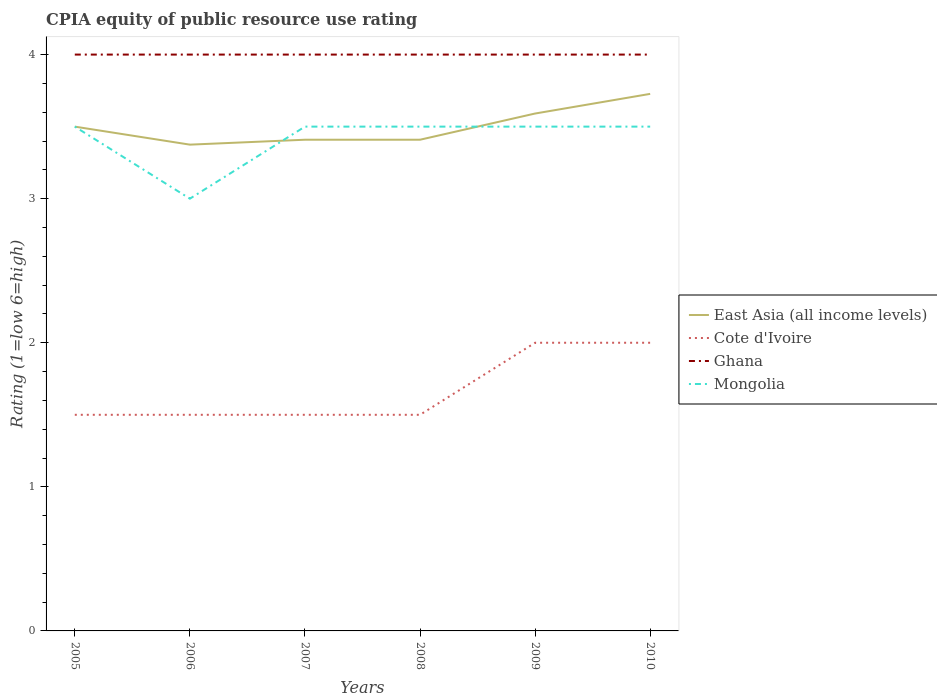How many different coloured lines are there?
Give a very brief answer. 4. Is the number of lines equal to the number of legend labels?
Ensure brevity in your answer.  Yes. Across all years, what is the maximum CPIA rating in East Asia (all income levels)?
Give a very brief answer. 3.38. What is the difference between the highest and the second highest CPIA rating in East Asia (all income levels)?
Give a very brief answer. 0.35. What is the difference between the highest and the lowest CPIA rating in Cote d'Ivoire?
Provide a succinct answer. 2. Does the graph contain grids?
Keep it short and to the point. No. Where does the legend appear in the graph?
Make the answer very short. Center right. How many legend labels are there?
Your answer should be very brief. 4. How are the legend labels stacked?
Provide a succinct answer. Vertical. What is the title of the graph?
Your response must be concise. CPIA equity of public resource use rating. What is the label or title of the X-axis?
Give a very brief answer. Years. What is the label or title of the Y-axis?
Ensure brevity in your answer.  Rating (1=low 6=high). What is the Rating (1=low 6=high) in East Asia (all income levels) in 2006?
Provide a succinct answer. 3.38. What is the Rating (1=low 6=high) of Cote d'Ivoire in 2006?
Your response must be concise. 1.5. What is the Rating (1=low 6=high) of Ghana in 2006?
Your response must be concise. 4. What is the Rating (1=low 6=high) in East Asia (all income levels) in 2007?
Give a very brief answer. 3.41. What is the Rating (1=low 6=high) of Cote d'Ivoire in 2007?
Your response must be concise. 1.5. What is the Rating (1=low 6=high) in Mongolia in 2007?
Offer a very short reply. 3.5. What is the Rating (1=low 6=high) of East Asia (all income levels) in 2008?
Your answer should be compact. 3.41. What is the Rating (1=low 6=high) in Cote d'Ivoire in 2008?
Make the answer very short. 1.5. What is the Rating (1=low 6=high) of Mongolia in 2008?
Your answer should be compact. 3.5. What is the Rating (1=low 6=high) of East Asia (all income levels) in 2009?
Offer a terse response. 3.59. What is the Rating (1=low 6=high) of Cote d'Ivoire in 2009?
Offer a very short reply. 2. What is the Rating (1=low 6=high) in Ghana in 2009?
Your answer should be very brief. 4. What is the Rating (1=low 6=high) of Mongolia in 2009?
Give a very brief answer. 3.5. What is the Rating (1=low 6=high) in East Asia (all income levels) in 2010?
Offer a terse response. 3.73. What is the Rating (1=low 6=high) in Mongolia in 2010?
Your answer should be compact. 3.5. Across all years, what is the maximum Rating (1=low 6=high) of East Asia (all income levels)?
Make the answer very short. 3.73. Across all years, what is the minimum Rating (1=low 6=high) in East Asia (all income levels)?
Provide a short and direct response. 3.38. What is the total Rating (1=low 6=high) in East Asia (all income levels) in the graph?
Offer a terse response. 21.01. What is the total Rating (1=low 6=high) of Cote d'Ivoire in the graph?
Offer a terse response. 10. What is the total Rating (1=low 6=high) in Ghana in the graph?
Provide a succinct answer. 24. What is the total Rating (1=low 6=high) of Mongolia in the graph?
Your response must be concise. 20.5. What is the difference between the Rating (1=low 6=high) in East Asia (all income levels) in 2005 and that in 2007?
Provide a succinct answer. 0.09. What is the difference between the Rating (1=low 6=high) in East Asia (all income levels) in 2005 and that in 2008?
Offer a terse response. 0.09. What is the difference between the Rating (1=low 6=high) in Cote d'Ivoire in 2005 and that in 2008?
Make the answer very short. 0. What is the difference between the Rating (1=low 6=high) of Ghana in 2005 and that in 2008?
Keep it short and to the point. 0. What is the difference between the Rating (1=low 6=high) of Mongolia in 2005 and that in 2008?
Ensure brevity in your answer.  0. What is the difference between the Rating (1=low 6=high) of East Asia (all income levels) in 2005 and that in 2009?
Your answer should be very brief. -0.09. What is the difference between the Rating (1=low 6=high) of East Asia (all income levels) in 2005 and that in 2010?
Your answer should be very brief. -0.23. What is the difference between the Rating (1=low 6=high) of Ghana in 2005 and that in 2010?
Offer a terse response. 0. What is the difference between the Rating (1=low 6=high) in East Asia (all income levels) in 2006 and that in 2007?
Your answer should be compact. -0.03. What is the difference between the Rating (1=low 6=high) of Ghana in 2006 and that in 2007?
Your answer should be compact. 0. What is the difference between the Rating (1=low 6=high) in Mongolia in 2006 and that in 2007?
Offer a very short reply. -0.5. What is the difference between the Rating (1=low 6=high) of East Asia (all income levels) in 2006 and that in 2008?
Provide a short and direct response. -0.03. What is the difference between the Rating (1=low 6=high) in Ghana in 2006 and that in 2008?
Your answer should be very brief. 0. What is the difference between the Rating (1=low 6=high) of Mongolia in 2006 and that in 2008?
Provide a succinct answer. -0.5. What is the difference between the Rating (1=low 6=high) in East Asia (all income levels) in 2006 and that in 2009?
Offer a terse response. -0.22. What is the difference between the Rating (1=low 6=high) in Mongolia in 2006 and that in 2009?
Your response must be concise. -0.5. What is the difference between the Rating (1=low 6=high) in East Asia (all income levels) in 2006 and that in 2010?
Your answer should be compact. -0.35. What is the difference between the Rating (1=low 6=high) in Cote d'Ivoire in 2006 and that in 2010?
Provide a succinct answer. -0.5. What is the difference between the Rating (1=low 6=high) of Ghana in 2006 and that in 2010?
Offer a terse response. 0. What is the difference between the Rating (1=low 6=high) of Mongolia in 2006 and that in 2010?
Offer a terse response. -0.5. What is the difference between the Rating (1=low 6=high) in East Asia (all income levels) in 2007 and that in 2008?
Provide a short and direct response. 0. What is the difference between the Rating (1=low 6=high) of Ghana in 2007 and that in 2008?
Give a very brief answer. 0. What is the difference between the Rating (1=low 6=high) in Mongolia in 2007 and that in 2008?
Offer a terse response. 0. What is the difference between the Rating (1=low 6=high) of East Asia (all income levels) in 2007 and that in 2009?
Your answer should be compact. -0.18. What is the difference between the Rating (1=low 6=high) in Cote d'Ivoire in 2007 and that in 2009?
Offer a terse response. -0.5. What is the difference between the Rating (1=low 6=high) of East Asia (all income levels) in 2007 and that in 2010?
Ensure brevity in your answer.  -0.32. What is the difference between the Rating (1=low 6=high) in Ghana in 2007 and that in 2010?
Give a very brief answer. 0. What is the difference between the Rating (1=low 6=high) of East Asia (all income levels) in 2008 and that in 2009?
Provide a succinct answer. -0.18. What is the difference between the Rating (1=low 6=high) in Ghana in 2008 and that in 2009?
Provide a short and direct response. 0. What is the difference between the Rating (1=low 6=high) of Mongolia in 2008 and that in 2009?
Give a very brief answer. 0. What is the difference between the Rating (1=low 6=high) of East Asia (all income levels) in 2008 and that in 2010?
Provide a succinct answer. -0.32. What is the difference between the Rating (1=low 6=high) in Ghana in 2008 and that in 2010?
Offer a terse response. 0. What is the difference between the Rating (1=low 6=high) of East Asia (all income levels) in 2009 and that in 2010?
Provide a succinct answer. -0.14. What is the difference between the Rating (1=low 6=high) in Ghana in 2009 and that in 2010?
Your response must be concise. 0. What is the difference between the Rating (1=low 6=high) of Mongolia in 2009 and that in 2010?
Your answer should be very brief. 0. What is the difference between the Rating (1=low 6=high) in East Asia (all income levels) in 2005 and the Rating (1=low 6=high) in Mongolia in 2006?
Offer a terse response. 0.5. What is the difference between the Rating (1=low 6=high) in Cote d'Ivoire in 2005 and the Rating (1=low 6=high) in Ghana in 2006?
Give a very brief answer. -2.5. What is the difference between the Rating (1=low 6=high) in Ghana in 2005 and the Rating (1=low 6=high) in Mongolia in 2006?
Your answer should be very brief. 1. What is the difference between the Rating (1=low 6=high) of East Asia (all income levels) in 2005 and the Rating (1=low 6=high) of Ghana in 2007?
Your answer should be compact. -0.5. What is the difference between the Rating (1=low 6=high) in Cote d'Ivoire in 2005 and the Rating (1=low 6=high) in Mongolia in 2007?
Make the answer very short. -2. What is the difference between the Rating (1=low 6=high) in Ghana in 2005 and the Rating (1=low 6=high) in Mongolia in 2007?
Offer a very short reply. 0.5. What is the difference between the Rating (1=low 6=high) of East Asia (all income levels) in 2005 and the Rating (1=low 6=high) of Cote d'Ivoire in 2008?
Ensure brevity in your answer.  2. What is the difference between the Rating (1=low 6=high) of East Asia (all income levels) in 2005 and the Rating (1=low 6=high) of Mongolia in 2008?
Give a very brief answer. 0. What is the difference between the Rating (1=low 6=high) of Cote d'Ivoire in 2005 and the Rating (1=low 6=high) of Mongolia in 2008?
Offer a terse response. -2. What is the difference between the Rating (1=low 6=high) of Ghana in 2005 and the Rating (1=low 6=high) of Mongolia in 2008?
Make the answer very short. 0.5. What is the difference between the Rating (1=low 6=high) in East Asia (all income levels) in 2005 and the Rating (1=low 6=high) in Cote d'Ivoire in 2009?
Provide a succinct answer. 1.5. What is the difference between the Rating (1=low 6=high) of East Asia (all income levels) in 2005 and the Rating (1=low 6=high) of Ghana in 2009?
Your response must be concise. -0.5. What is the difference between the Rating (1=low 6=high) in Ghana in 2005 and the Rating (1=low 6=high) in Mongolia in 2009?
Your answer should be very brief. 0.5. What is the difference between the Rating (1=low 6=high) in East Asia (all income levels) in 2005 and the Rating (1=low 6=high) in Cote d'Ivoire in 2010?
Your answer should be compact. 1.5. What is the difference between the Rating (1=low 6=high) in East Asia (all income levels) in 2005 and the Rating (1=low 6=high) in Ghana in 2010?
Give a very brief answer. -0.5. What is the difference between the Rating (1=low 6=high) in East Asia (all income levels) in 2005 and the Rating (1=low 6=high) in Mongolia in 2010?
Your answer should be very brief. 0. What is the difference between the Rating (1=low 6=high) of Ghana in 2005 and the Rating (1=low 6=high) of Mongolia in 2010?
Your answer should be very brief. 0.5. What is the difference between the Rating (1=low 6=high) in East Asia (all income levels) in 2006 and the Rating (1=low 6=high) in Cote d'Ivoire in 2007?
Make the answer very short. 1.88. What is the difference between the Rating (1=low 6=high) in East Asia (all income levels) in 2006 and the Rating (1=low 6=high) in Ghana in 2007?
Your answer should be very brief. -0.62. What is the difference between the Rating (1=low 6=high) of East Asia (all income levels) in 2006 and the Rating (1=low 6=high) of Mongolia in 2007?
Offer a terse response. -0.12. What is the difference between the Rating (1=low 6=high) of Cote d'Ivoire in 2006 and the Rating (1=low 6=high) of Ghana in 2007?
Your response must be concise. -2.5. What is the difference between the Rating (1=low 6=high) in East Asia (all income levels) in 2006 and the Rating (1=low 6=high) in Cote d'Ivoire in 2008?
Provide a short and direct response. 1.88. What is the difference between the Rating (1=low 6=high) in East Asia (all income levels) in 2006 and the Rating (1=low 6=high) in Ghana in 2008?
Provide a short and direct response. -0.62. What is the difference between the Rating (1=low 6=high) in East Asia (all income levels) in 2006 and the Rating (1=low 6=high) in Mongolia in 2008?
Keep it short and to the point. -0.12. What is the difference between the Rating (1=low 6=high) in Cote d'Ivoire in 2006 and the Rating (1=low 6=high) in Ghana in 2008?
Your answer should be compact. -2.5. What is the difference between the Rating (1=low 6=high) in Cote d'Ivoire in 2006 and the Rating (1=low 6=high) in Mongolia in 2008?
Offer a very short reply. -2. What is the difference between the Rating (1=low 6=high) in Ghana in 2006 and the Rating (1=low 6=high) in Mongolia in 2008?
Make the answer very short. 0.5. What is the difference between the Rating (1=low 6=high) in East Asia (all income levels) in 2006 and the Rating (1=low 6=high) in Cote d'Ivoire in 2009?
Give a very brief answer. 1.38. What is the difference between the Rating (1=low 6=high) in East Asia (all income levels) in 2006 and the Rating (1=low 6=high) in Ghana in 2009?
Provide a short and direct response. -0.62. What is the difference between the Rating (1=low 6=high) in East Asia (all income levels) in 2006 and the Rating (1=low 6=high) in Mongolia in 2009?
Offer a very short reply. -0.12. What is the difference between the Rating (1=low 6=high) of Cote d'Ivoire in 2006 and the Rating (1=low 6=high) of Ghana in 2009?
Give a very brief answer. -2.5. What is the difference between the Rating (1=low 6=high) of Cote d'Ivoire in 2006 and the Rating (1=low 6=high) of Mongolia in 2009?
Give a very brief answer. -2. What is the difference between the Rating (1=low 6=high) of Ghana in 2006 and the Rating (1=low 6=high) of Mongolia in 2009?
Give a very brief answer. 0.5. What is the difference between the Rating (1=low 6=high) in East Asia (all income levels) in 2006 and the Rating (1=low 6=high) in Cote d'Ivoire in 2010?
Provide a succinct answer. 1.38. What is the difference between the Rating (1=low 6=high) in East Asia (all income levels) in 2006 and the Rating (1=low 6=high) in Ghana in 2010?
Make the answer very short. -0.62. What is the difference between the Rating (1=low 6=high) of East Asia (all income levels) in 2006 and the Rating (1=low 6=high) of Mongolia in 2010?
Your response must be concise. -0.12. What is the difference between the Rating (1=low 6=high) of Cote d'Ivoire in 2006 and the Rating (1=low 6=high) of Ghana in 2010?
Provide a succinct answer. -2.5. What is the difference between the Rating (1=low 6=high) of Cote d'Ivoire in 2006 and the Rating (1=low 6=high) of Mongolia in 2010?
Your answer should be compact. -2. What is the difference between the Rating (1=low 6=high) in East Asia (all income levels) in 2007 and the Rating (1=low 6=high) in Cote d'Ivoire in 2008?
Make the answer very short. 1.91. What is the difference between the Rating (1=low 6=high) in East Asia (all income levels) in 2007 and the Rating (1=low 6=high) in Ghana in 2008?
Provide a short and direct response. -0.59. What is the difference between the Rating (1=low 6=high) in East Asia (all income levels) in 2007 and the Rating (1=low 6=high) in Mongolia in 2008?
Your response must be concise. -0.09. What is the difference between the Rating (1=low 6=high) in Cote d'Ivoire in 2007 and the Rating (1=low 6=high) in Mongolia in 2008?
Offer a very short reply. -2. What is the difference between the Rating (1=low 6=high) in East Asia (all income levels) in 2007 and the Rating (1=low 6=high) in Cote d'Ivoire in 2009?
Provide a short and direct response. 1.41. What is the difference between the Rating (1=low 6=high) of East Asia (all income levels) in 2007 and the Rating (1=low 6=high) of Ghana in 2009?
Keep it short and to the point. -0.59. What is the difference between the Rating (1=low 6=high) of East Asia (all income levels) in 2007 and the Rating (1=low 6=high) of Mongolia in 2009?
Make the answer very short. -0.09. What is the difference between the Rating (1=low 6=high) in Cote d'Ivoire in 2007 and the Rating (1=low 6=high) in Mongolia in 2009?
Offer a very short reply. -2. What is the difference between the Rating (1=low 6=high) of Ghana in 2007 and the Rating (1=low 6=high) of Mongolia in 2009?
Provide a short and direct response. 0.5. What is the difference between the Rating (1=low 6=high) in East Asia (all income levels) in 2007 and the Rating (1=low 6=high) in Cote d'Ivoire in 2010?
Make the answer very short. 1.41. What is the difference between the Rating (1=low 6=high) of East Asia (all income levels) in 2007 and the Rating (1=low 6=high) of Ghana in 2010?
Your answer should be very brief. -0.59. What is the difference between the Rating (1=low 6=high) of East Asia (all income levels) in 2007 and the Rating (1=low 6=high) of Mongolia in 2010?
Provide a short and direct response. -0.09. What is the difference between the Rating (1=low 6=high) in Cote d'Ivoire in 2007 and the Rating (1=low 6=high) in Ghana in 2010?
Keep it short and to the point. -2.5. What is the difference between the Rating (1=low 6=high) of Ghana in 2007 and the Rating (1=low 6=high) of Mongolia in 2010?
Make the answer very short. 0.5. What is the difference between the Rating (1=low 6=high) of East Asia (all income levels) in 2008 and the Rating (1=low 6=high) of Cote d'Ivoire in 2009?
Your answer should be compact. 1.41. What is the difference between the Rating (1=low 6=high) of East Asia (all income levels) in 2008 and the Rating (1=low 6=high) of Ghana in 2009?
Provide a short and direct response. -0.59. What is the difference between the Rating (1=low 6=high) of East Asia (all income levels) in 2008 and the Rating (1=low 6=high) of Mongolia in 2009?
Give a very brief answer. -0.09. What is the difference between the Rating (1=low 6=high) in Cote d'Ivoire in 2008 and the Rating (1=low 6=high) in Ghana in 2009?
Keep it short and to the point. -2.5. What is the difference between the Rating (1=low 6=high) in East Asia (all income levels) in 2008 and the Rating (1=low 6=high) in Cote d'Ivoire in 2010?
Provide a short and direct response. 1.41. What is the difference between the Rating (1=low 6=high) in East Asia (all income levels) in 2008 and the Rating (1=low 6=high) in Ghana in 2010?
Provide a short and direct response. -0.59. What is the difference between the Rating (1=low 6=high) of East Asia (all income levels) in 2008 and the Rating (1=low 6=high) of Mongolia in 2010?
Keep it short and to the point. -0.09. What is the difference between the Rating (1=low 6=high) in Cote d'Ivoire in 2008 and the Rating (1=low 6=high) in Mongolia in 2010?
Ensure brevity in your answer.  -2. What is the difference between the Rating (1=low 6=high) in East Asia (all income levels) in 2009 and the Rating (1=low 6=high) in Cote d'Ivoire in 2010?
Offer a very short reply. 1.59. What is the difference between the Rating (1=low 6=high) in East Asia (all income levels) in 2009 and the Rating (1=low 6=high) in Ghana in 2010?
Your response must be concise. -0.41. What is the difference between the Rating (1=low 6=high) in East Asia (all income levels) in 2009 and the Rating (1=low 6=high) in Mongolia in 2010?
Your answer should be very brief. 0.09. What is the difference between the Rating (1=low 6=high) of Cote d'Ivoire in 2009 and the Rating (1=low 6=high) of Mongolia in 2010?
Provide a short and direct response. -1.5. What is the average Rating (1=low 6=high) of East Asia (all income levels) per year?
Provide a short and direct response. 3.5. What is the average Rating (1=low 6=high) of Cote d'Ivoire per year?
Provide a short and direct response. 1.67. What is the average Rating (1=low 6=high) of Mongolia per year?
Make the answer very short. 3.42. In the year 2005, what is the difference between the Rating (1=low 6=high) in East Asia (all income levels) and Rating (1=low 6=high) in Cote d'Ivoire?
Keep it short and to the point. 2. In the year 2005, what is the difference between the Rating (1=low 6=high) of East Asia (all income levels) and Rating (1=low 6=high) of Ghana?
Provide a short and direct response. -0.5. In the year 2005, what is the difference between the Rating (1=low 6=high) of Cote d'Ivoire and Rating (1=low 6=high) of Ghana?
Your answer should be compact. -2.5. In the year 2005, what is the difference between the Rating (1=low 6=high) in Cote d'Ivoire and Rating (1=low 6=high) in Mongolia?
Make the answer very short. -2. In the year 2006, what is the difference between the Rating (1=low 6=high) in East Asia (all income levels) and Rating (1=low 6=high) in Cote d'Ivoire?
Keep it short and to the point. 1.88. In the year 2006, what is the difference between the Rating (1=low 6=high) in East Asia (all income levels) and Rating (1=low 6=high) in Ghana?
Provide a short and direct response. -0.62. In the year 2006, what is the difference between the Rating (1=low 6=high) in Cote d'Ivoire and Rating (1=low 6=high) in Ghana?
Your answer should be very brief. -2.5. In the year 2006, what is the difference between the Rating (1=low 6=high) in Ghana and Rating (1=low 6=high) in Mongolia?
Keep it short and to the point. 1. In the year 2007, what is the difference between the Rating (1=low 6=high) of East Asia (all income levels) and Rating (1=low 6=high) of Cote d'Ivoire?
Your answer should be compact. 1.91. In the year 2007, what is the difference between the Rating (1=low 6=high) of East Asia (all income levels) and Rating (1=low 6=high) of Ghana?
Provide a short and direct response. -0.59. In the year 2007, what is the difference between the Rating (1=low 6=high) of East Asia (all income levels) and Rating (1=low 6=high) of Mongolia?
Your answer should be compact. -0.09. In the year 2007, what is the difference between the Rating (1=low 6=high) in Cote d'Ivoire and Rating (1=low 6=high) in Ghana?
Your response must be concise. -2.5. In the year 2007, what is the difference between the Rating (1=low 6=high) in Ghana and Rating (1=low 6=high) in Mongolia?
Offer a very short reply. 0.5. In the year 2008, what is the difference between the Rating (1=low 6=high) of East Asia (all income levels) and Rating (1=low 6=high) of Cote d'Ivoire?
Give a very brief answer. 1.91. In the year 2008, what is the difference between the Rating (1=low 6=high) in East Asia (all income levels) and Rating (1=low 6=high) in Ghana?
Provide a short and direct response. -0.59. In the year 2008, what is the difference between the Rating (1=low 6=high) in East Asia (all income levels) and Rating (1=low 6=high) in Mongolia?
Provide a succinct answer. -0.09. In the year 2009, what is the difference between the Rating (1=low 6=high) of East Asia (all income levels) and Rating (1=low 6=high) of Cote d'Ivoire?
Your response must be concise. 1.59. In the year 2009, what is the difference between the Rating (1=low 6=high) in East Asia (all income levels) and Rating (1=low 6=high) in Ghana?
Keep it short and to the point. -0.41. In the year 2009, what is the difference between the Rating (1=low 6=high) in East Asia (all income levels) and Rating (1=low 6=high) in Mongolia?
Ensure brevity in your answer.  0.09. In the year 2009, what is the difference between the Rating (1=low 6=high) of Cote d'Ivoire and Rating (1=low 6=high) of Ghana?
Offer a very short reply. -2. In the year 2009, what is the difference between the Rating (1=low 6=high) of Ghana and Rating (1=low 6=high) of Mongolia?
Provide a short and direct response. 0.5. In the year 2010, what is the difference between the Rating (1=low 6=high) in East Asia (all income levels) and Rating (1=low 6=high) in Cote d'Ivoire?
Ensure brevity in your answer.  1.73. In the year 2010, what is the difference between the Rating (1=low 6=high) of East Asia (all income levels) and Rating (1=low 6=high) of Ghana?
Provide a short and direct response. -0.27. In the year 2010, what is the difference between the Rating (1=low 6=high) of East Asia (all income levels) and Rating (1=low 6=high) of Mongolia?
Make the answer very short. 0.23. In the year 2010, what is the difference between the Rating (1=low 6=high) of Cote d'Ivoire and Rating (1=low 6=high) of Ghana?
Ensure brevity in your answer.  -2. In the year 2010, what is the difference between the Rating (1=low 6=high) of Ghana and Rating (1=low 6=high) of Mongolia?
Offer a terse response. 0.5. What is the ratio of the Rating (1=low 6=high) in Mongolia in 2005 to that in 2006?
Offer a terse response. 1.17. What is the ratio of the Rating (1=low 6=high) in East Asia (all income levels) in 2005 to that in 2007?
Ensure brevity in your answer.  1.03. What is the ratio of the Rating (1=low 6=high) in Cote d'Ivoire in 2005 to that in 2007?
Your answer should be very brief. 1. What is the ratio of the Rating (1=low 6=high) in Mongolia in 2005 to that in 2007?
Offer a terse response. 1. What is the ratio of the Rating (1=low 6=high) in East Asia (all income levels) in 2005 to that in 2008?
Keep it short and to the point. 1.03. What is the ratio of the Rating (1=low 6=high) of East Asia (all income levels) in 2005 to that in 2009?
Make the answer very short. 0.97. What is the ratio of the Rating (1=low 6=high) in Cote d'Ivoire in 2005 to that in 2009?
Offer a terse response. 0.75. What is the ratio of the Rating (1=low 6=high) in Ghana in 2005 to that in 2009?
Offer a terse response. 1. What is the ratio of the Rating (1=low 6=high) in East Asia (all income levels) in 2005 to that in 2010?
Offer a very short reply. 0.94. What is the ratio of the Rating (1=low 6=high) in Cote d'Ivoire in 2005 to that in 2010?
Your response must be concise. 0.75. What is the ratio of the Rating (1=low 6=high) in Cote d'Ivoire in 2006 to that in 2008?
Provide a short and direct response. 1. What is the ratio of the Rating (1=low 6=high) in Ghana in 2006 to that in 2008?
Your response must be concise. 1. What is the ratio of the Rating (1=low 6=high) of Mongolia in 2006 to that in 2008?
Provide a short and direct response. 0.86. What is the ratio of the Rating (1=low 6=high) in East Asia (all income levels) in 2006 to that in 2009?
Provide a succinct answer. 0.94. What is the ratio of the Rating (1=low 6=high) of Cote d'Ivoire in 2006 to that in 2009?
Keep it short and to the point. 0.75. What is the ratio of the Rating (1=low 6=high) of Mongolia in 2006 to that in 2009?
Your response must be concise. 0.86. What is the ratio of the Rating (1=low 6=high) in East Asia (all income levels) in 2006 to that in 2010?
Ensure brevity in your answer.  0.91. What is the ratio of the Rating (1=low 6=high) in Cote d'Ivoire in 2006 to that in 2010?
Make the answer very short. 0.75. What is the ratio of the Rating (1=low 6=high) of East Asia (all income levels) in 2007 to that in 2008?
Ensure brevity in your answer.  1. What is the ratio of the Rating (1=low 6=high) in Cote d'Ivoire in 2007 to that in 2008?
Offer a very short reply. 1. What is the ratio of the Rating (1=low 6=high) in Ghana in 2007 to that in 2008?
Offer a very short reply. 1. What is the ratio of the Rating (1=low 6=high) in Mongolia in 2007 to that in 2008?
Provide a succinct answer. 1. What is the ratio of the Rating (1=low 6=high) in East Asia (all income levels) in 2007 to that in 2009?
Your response must be concise. 0.95. What is the ratio of the Rating (1=low 6=high) in Cote d'Ivoire in 2007 to that in 2009?
Keep it short and to the point. 0.75. What is the ratio of the Rating (1=low 6=high) in Mongolia in 2007 to that in 2009?
Offer a terse response. 1. What is the ratio of the Rating (1=low 6=high) in East Asia (all income levels) in 2007 to that in 2010?
Make the answer very short. 0.91. What is the ratio of the Rating (1=low 6=high) in Cote d'Ivoire in 2007 to that in 2010?
Provide a succinct answer. 0.75. What is the ratio of the Rating (1=low 6=high) of Ghana in 2007 to that in 2010?
Offer a terse response. 1. What is the ratio of the Rating (1=low 6=high) of Mongolia in 2007 to that in 2010?
Ensure brevity in your answer.  1. What is the ratio of the Rating (1=low 6=high) of East Asia (all income levels) in 2008 to that in 2009?
Offer a very short reply. 0.95. What is the ratio of the Rating (1=low 6=high) in Ghana in 2008 to that in 2009?
Offer a very short reply. 1. What is the ratio of the Rating (1=low 6=high) in East Asia (all income levels) in 2008 to that in 2010?
Ensure brevity in your answer.  0.91. What is the ratio of the Rating (1=low 6=high) in Cote d'Ivoire in 2008 to that in 2010?
Make the answer very short. 0.75. What is the ratio of the Rating (1=low 6=high) of Ghana in 2008 to that in 2010?
Ensure brevity in your answer.  1. What is the ratio of the Rating (1=low 6=high) in East Asia (all income levels) in 2009 to that in 2010?
Your answer should be very brief. 0.96. What is the ratio of the Rating (1=low 6=high) of Cote d'Ivoire in 2009 to that in 2010?
Offer a terse response. 1. What is the ratio of the Rating (1=low 6=high) of Ghana in 2009 to that in 2010?
Make the answer very short. 1. What is the difference between the highest and the second highest Rating (1=low 6=high) of East Asia (all income levels)?
Your answer should be very brief. 0.14. What is the difference between the highest and the second highest Rating (1=low 6=high) of Ghana?
Offer a terse response. 0. What is the difference between the highest and the second highest Rating (1=low 6=high) of Mongolia?
Offer a very short reply. 0. What is the difference between the highest and the lowest Rating (1=low 6=high) of East Asia (all income levels)?
Offer a terse response. 0.35. 